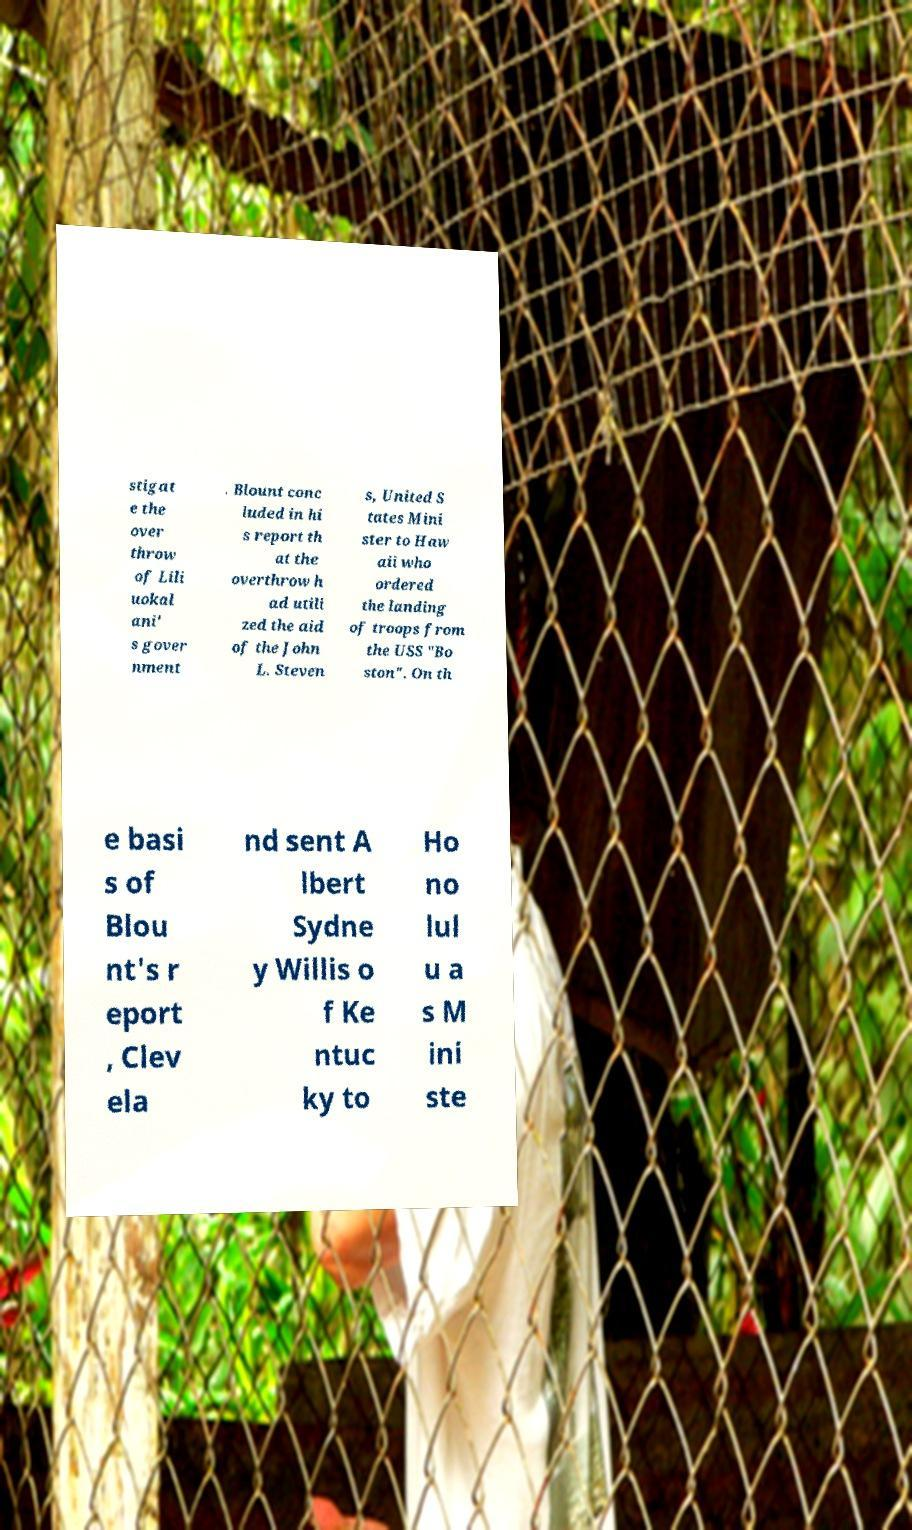What messages or text are displayed in this image? I need them in a readable, typed format. stigat e the over throw of Lili uokal ani' s gover nment . Blount conc luded in hi s report th at the overthrow h ad utili zed the aid of the John L. Steven s, United S tates Mini ster to Haw aii who ordered the landing of troops from the USS "Bo ston". On th e basi s of Blou nt's r eport , Clev ela nd sent A lbert Sydne y Willis o f Ke ntuc ky to Ho no lul u a s M ini ste 